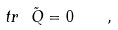<formula> <loc_0><loc_0><loc_500><loc_500>t r \ \tilde { Q } = 0 \quad ,</formula> 